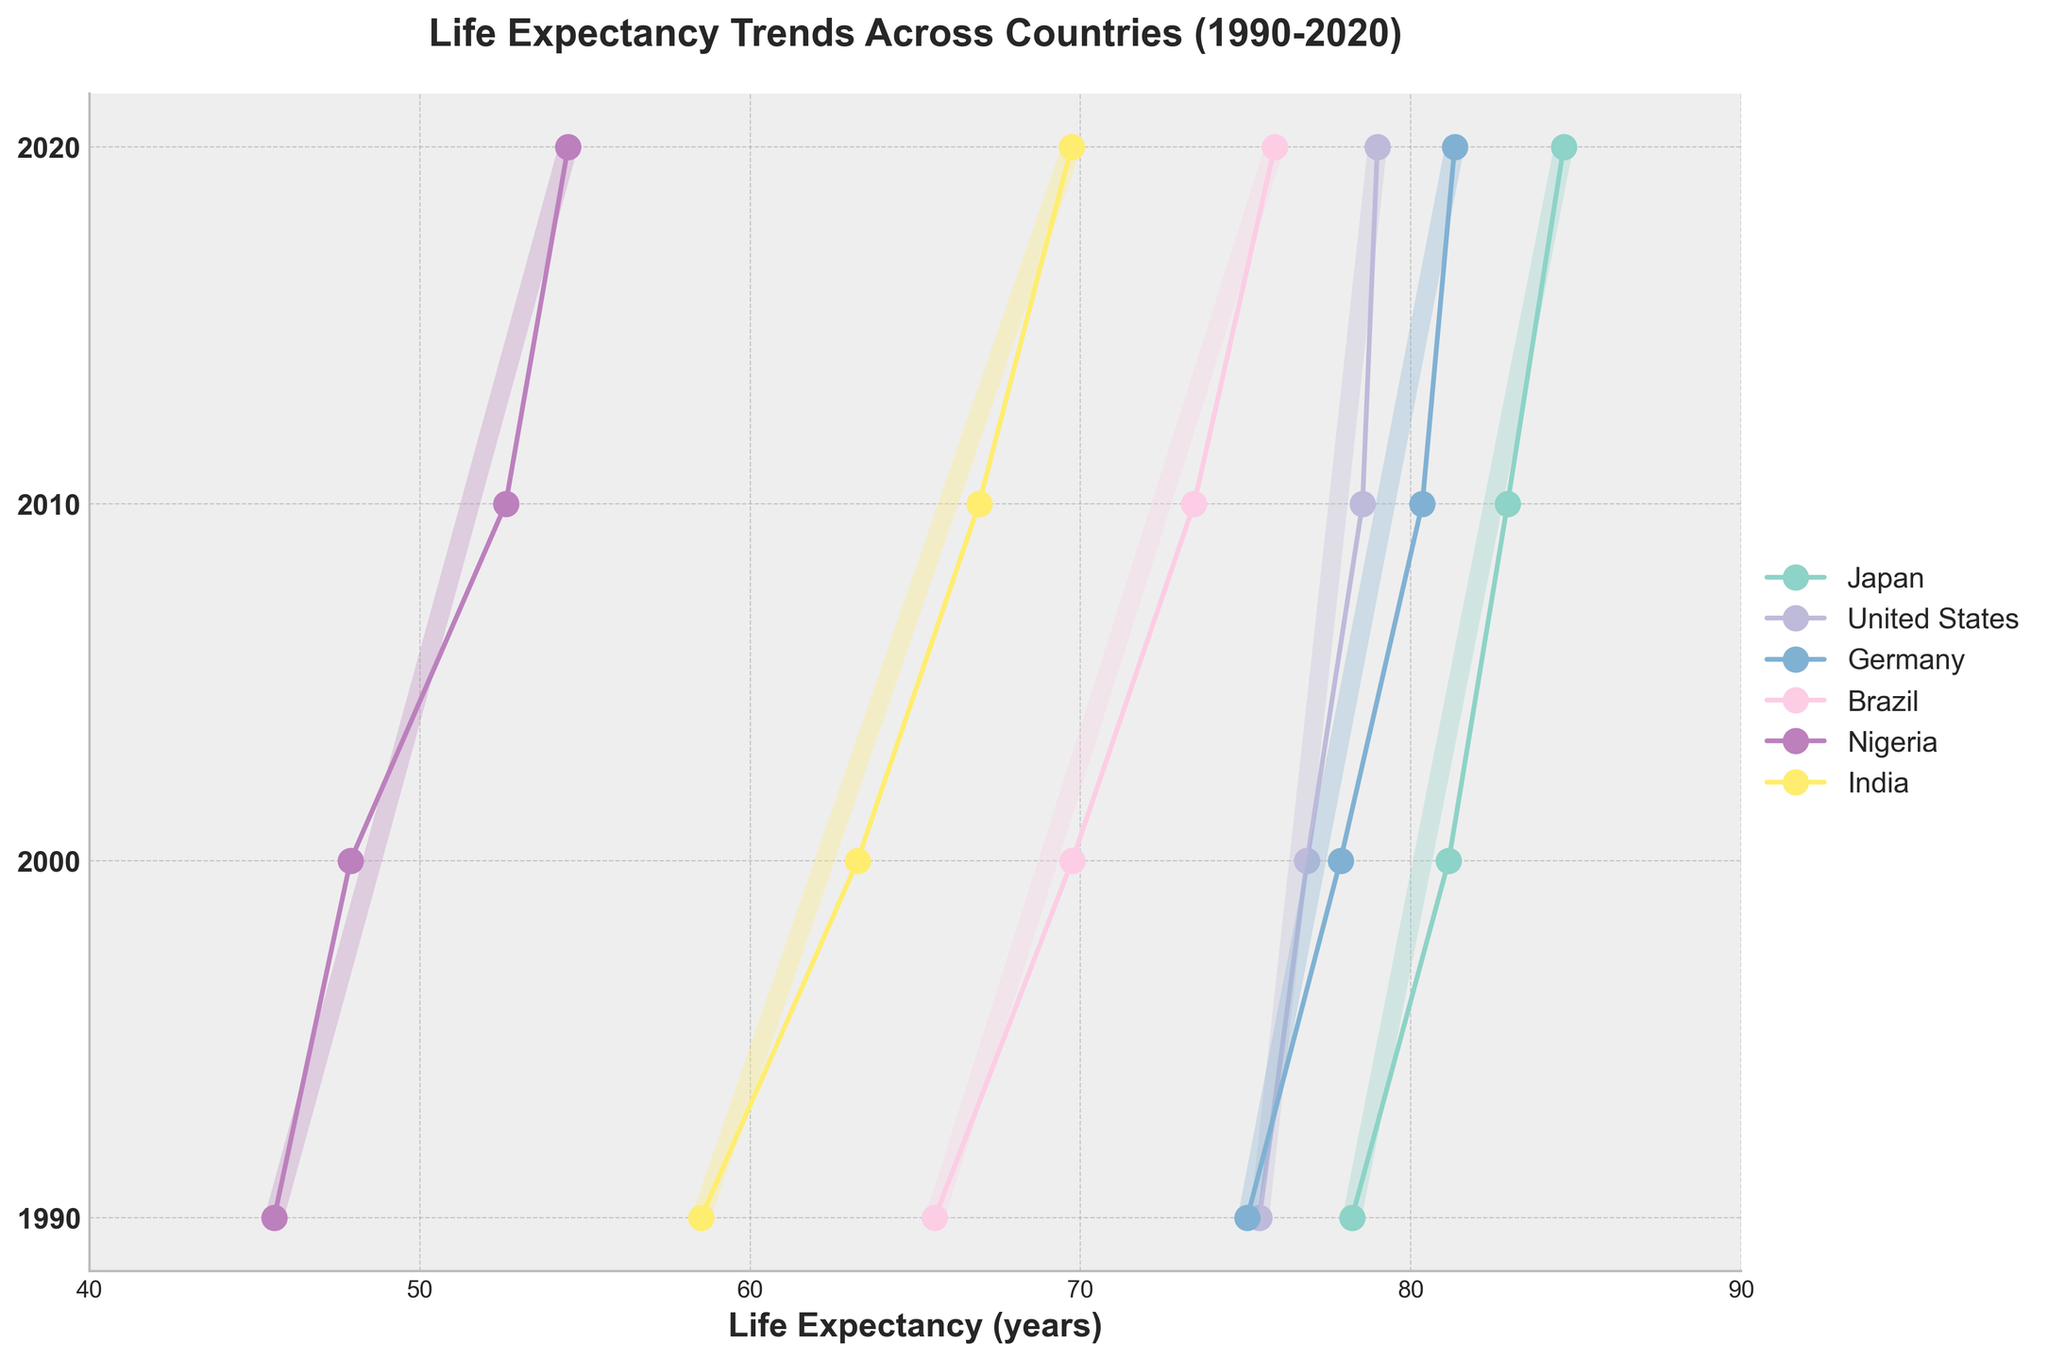How many countries are represented in the plot? The plot includes labeled points for individual countries. By counting unique country names, we see Japan, United States, Germany, Brazil, Nigeria, and India. There are 6 countries represented.
Answer: 6 Which country shows the highest life expectancy in 2020? By locating the 2020 points on the right side of the plot and comparing their positions, it can be observed that Japan's 2020 point is higher than those of other countries.
Answer: Japan What is the average life expectancy for Brazil over the years shown? To find the average, sum Brazil's life expectancy values (65.59, 69.75, 73.44, 75.88) and divide by 4, the number of data points. (65.59 + 69.75 + 73.44 + 75.88) / 4 = 71.665
Answer: 71.67 Which country had the smallest increase in life expectancy from 1990 to 2020? Calculate the increase for each country by subtracting the 1990 value from the 2020 value: Japan (84.63 - 78.22), United States (78.99 - 75.42), Germany (81.33 - 75.05), Brazil (75.88 - 65.59), Nigeria (54.49 - 45.59), India (69.73 - 58.51). The smallest increase is for the United States: 3.57 years.
Answer: United States How did Nigeria's life expectancy change from 1990 to 2000? Find and compare Nigeria's plot points for 1990 and 2000. The life expectancy in 1990 is 45.59, and in 2000 it is 47.90. The change is 47.90 - 45.59 = 2.31.
Answer: Increased by 2.31 years Which country's life expectancy increased the most between 2010 and 2020? Calculate the increase for each country by subtracting the 2010 value from the 2020 value: Japan (84.63 - 82.93), United States (78.99 - 78.54), Germany (81.33 - 80.35), Brazil (75.88 - 73.44), Nigeria (54.49 - 52.60), India (69.73 - 66.93). The largest increase is for Brazil: 2.44 years.
Answer: Brazil Which two countries had nearly equal life expectancy in 1990, and what was that value? By comparing the 1990 points horizontally, it appears that United States and Germany have nearly equal life expectancy values around 75.
Answer: United States and Germany, around 75 years What is the overall trend in life expectancy from 1990 to 2020, based on the plot? Observing each country's plotted points, life expectancy values generally increase over time from 1990 to 2020, showing an overall upward trend.
Answer: Upward trend How many years did it take Japan to reach a life expectancy over 80 years? Find when Japan's life expectancy first surpassed 80 by locating points for Japan and comparing them to 80. In 2000, Japan's expectancy was already 81.15. It took from the start in 1990 to 2000, so 10 years.
Answer: 10 years Which region shows the greatest variation in life expectancy within a single year? For each year, check vertical lines connecting life expectancies of countries within regions. In 1990, there is a large gap between Nigeria (45.59) and other regions. Africa shows the greatest variation.
Answer: Africa 